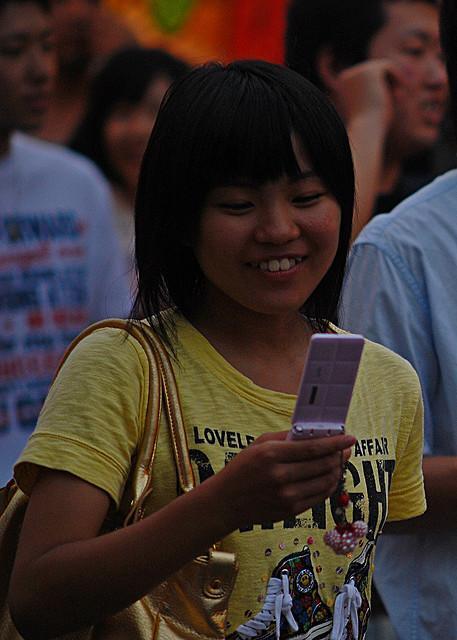What is there a picture of on the yellow shirt?
Pick the correct solution from the four options below to address the question.
Options: Elves, swords, cows, shoes. Shoes. 